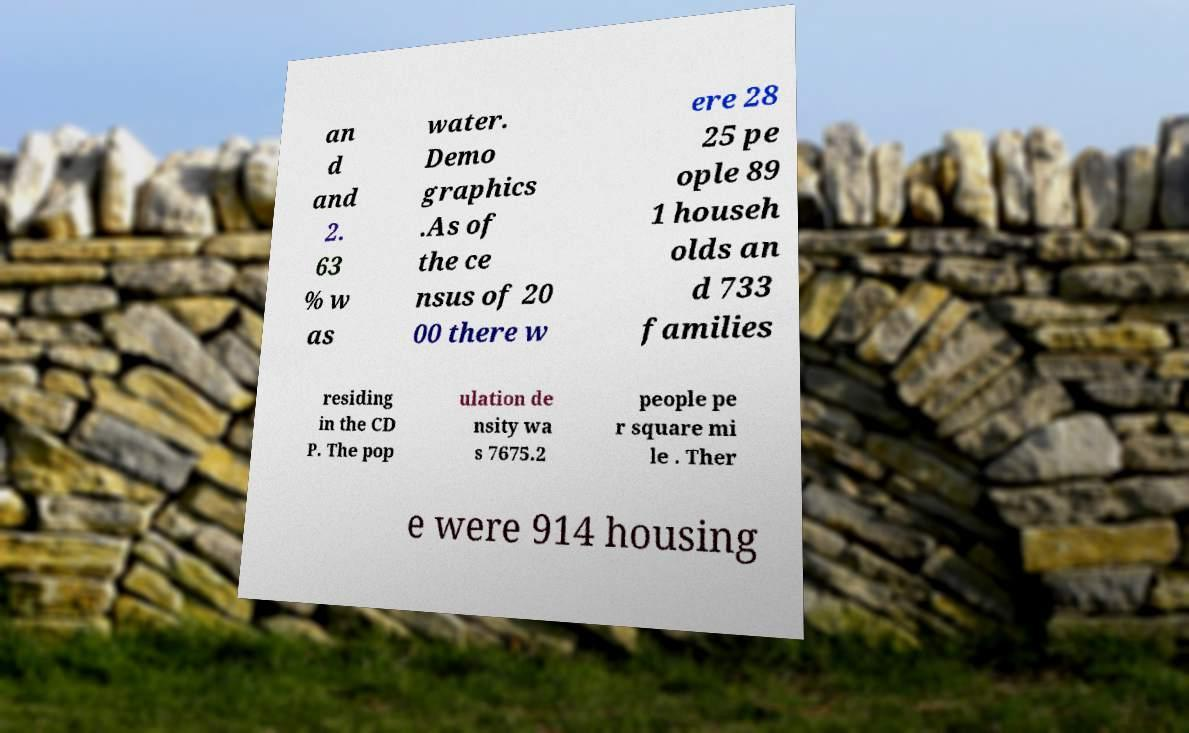For documentation purposes, I need the text within this image transcribed. Could you provide that? an d and 2. 63 % w as water. Demo graphics .As of the ce nsus of 20 00 there w ere 28 25 pe ople 89 1 househ olds an d 733 families residing in the CD P. The pop ulation de nsity wa s 7675.2 people pe r square mi le . Ther e were 914 housing 